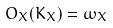<formula> <loc_0><loc_0><loc_500><loc_500>O _ { X } ( K _ { X } ) = \omega _ { X }</formula> 